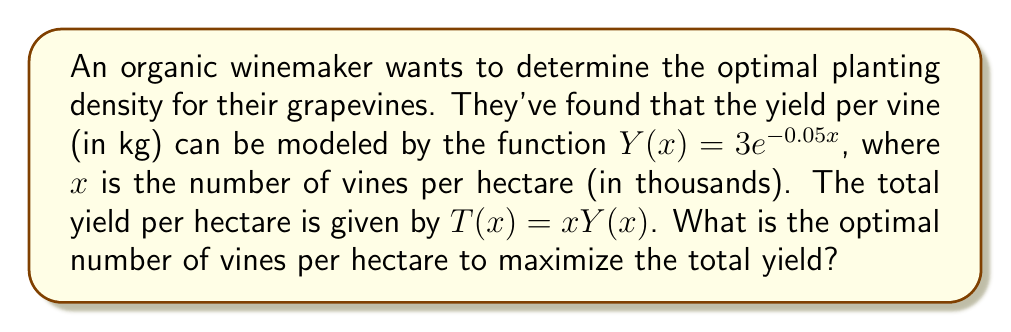Help me with this question. To find the optimal number of vines per hectare, we need to maximize the total yield function $T(x)$.

1. Express the total yield function:
   $T(x) = xY(x) = x(3e^{-0.05x}) = 3xe^{-0.05x}$

2. To find the maximum, we need to find the derivative of $T(x)$ and set it equal to zero:
   $$\frac{dT}{dx} = 3e^{-0.05x} + 3x(-0.05e^{-0.05x}) = 3e^{-0.05x}(1 - 0.05x)$$

3. Set the derivative equal to zero and solve for x:
   $$3e^{-0.05x}(1 - 0.05x) = 0$$
   $$1 - 0.05x = 0$$
   $$0.05x = 1$$
   $$x = 20$$

4. Verify that this is a maximum by checking the second derivative:
   $$\frac{d^2T}{dx^2} = 3e^{-0.05x}(-0.05)(1 - 0.05x) + 3e^{-0.05x}(-0.05) = 3e^{-0.05x}(-0.05)(2 - 0.05x)$$
   At $x = 20$, this is negative, confirming a maximum.

5. The optimal number of vines is 20 thousand per hectare, or 20,000 vines per hectare.
Answer: 20,000 vines per hectare 